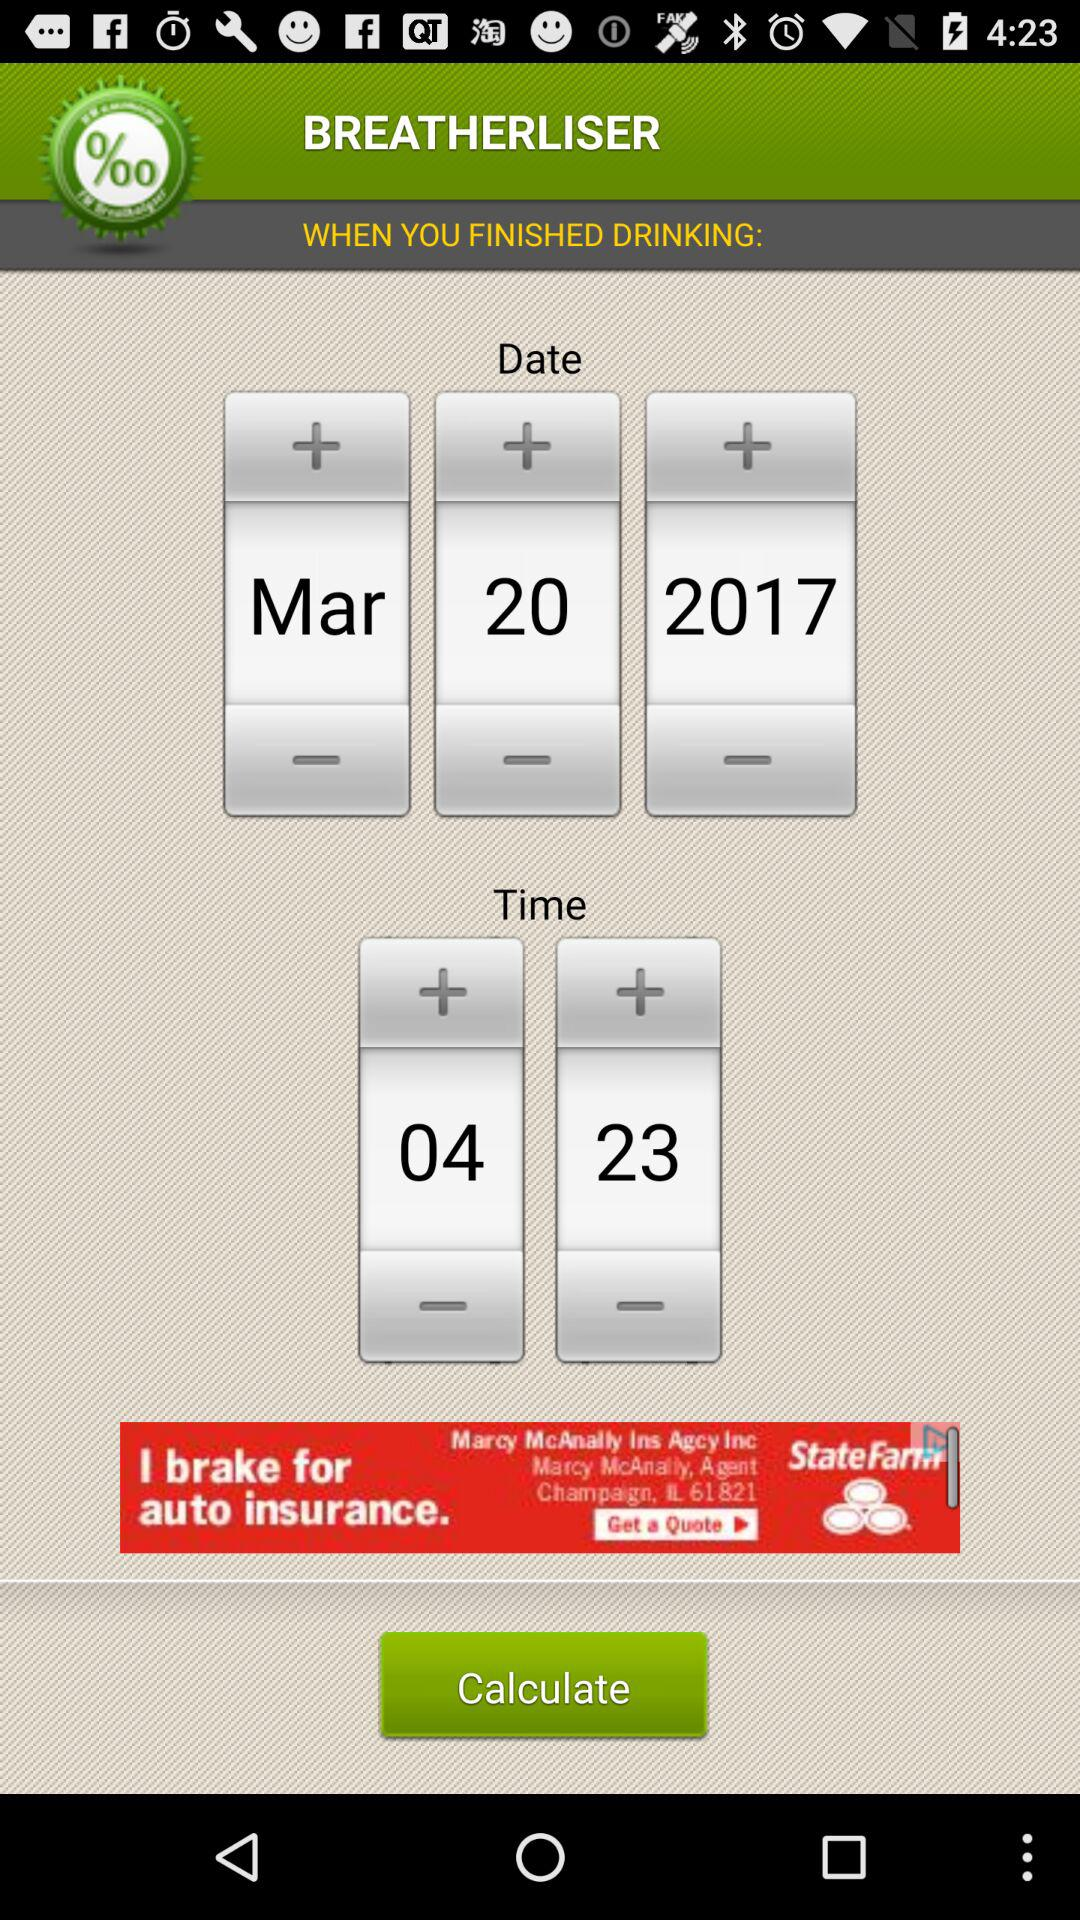What is the selected date? The selected date is March 20, 2017. 